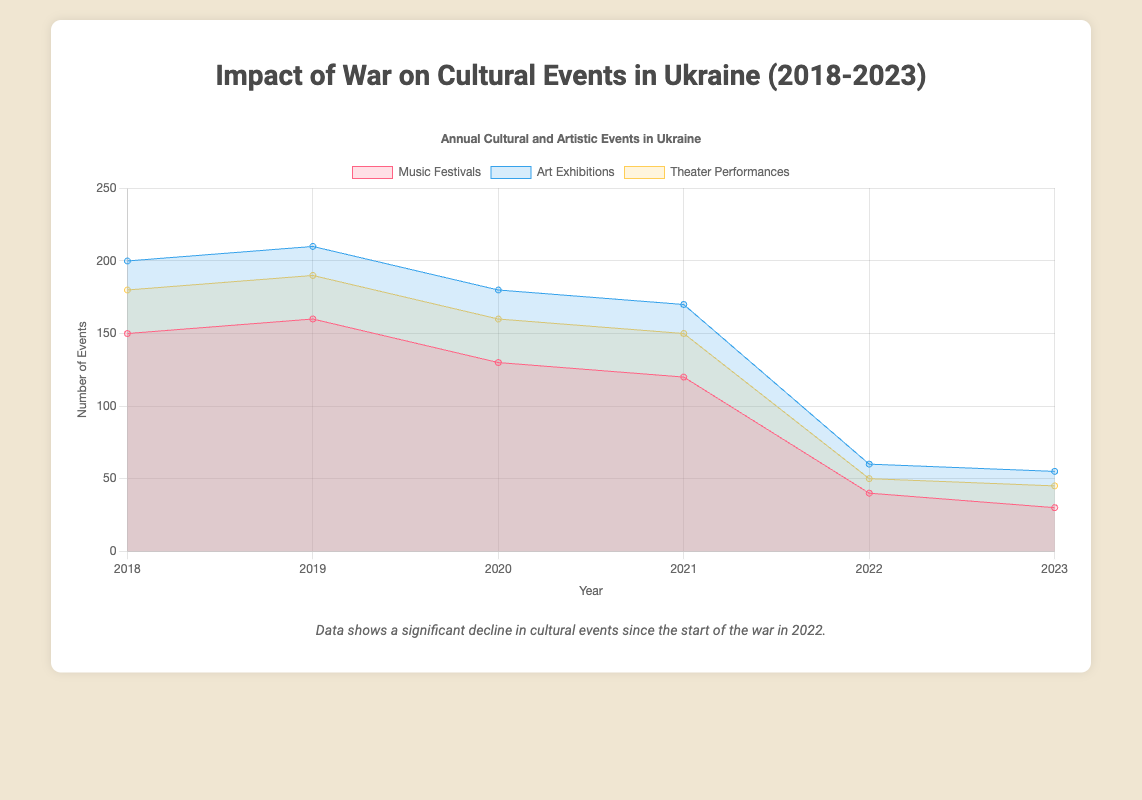What is the title of the chart? The title of the chart is located at the top and indicates the main topic of the visualization. In this case, it reads "Impact of War on Cultural Events in Ukraine (2018-2023)".
Answer: Impact of War on Cultural Events in Ukraine (2018-2023) How many event types are shown in the chart? The chart presents three different lines, each representing a different type of cultural event: Music Festivals, Art Exhibitions, and Theater Performances.
Answer: Three Which year had the highest total number of events across all event types? By visually adding up the total number of events for each year, 2019 shows a peak with maxima for Music Festivals (160), Art Exhibitions (210), and Theater Performances (190). Summing these we get 560, higher than any other year.
Answer: 2019 What is the overall trend in the number of events for 'Music Festivals' from 2018 to 2023? Observing the line representing Music Festivals, the trend is a steady decline from 150 events in 2018 to 30 events in 2023.
Answer: Decline What is the difference in the number of 'Theater Performances' between 2021 and 2022? In 2021, the number of Theater Performances was 150. In 2022, it dropped to 50. The difference is 150 - 50 = 100 events.
Answer: 100 Which event type experienced the most significant drop between 2021 and 2022? Comparing the drop in each event type's frequency: Music Festivals (120 to 40, a drop of 80), Art Exhibitions (170 to 60, a drop of 110), and Theater Performances (150 to 50, a drop of 100). Art Exhibitions experienced the largest drop of 110 events.
Answer: Art Exhibitions What is the total number of events for 'Art Exhibitions' over the entire period from 2018 to 2023? Summing up the number of Art Exhibitions for each year: 200 (2018) + 210 (2019) + 180 (2020) + 170 (2021) + 60 (2022) + 55 (2023) results in a total of 875 events.
Answer: 875 Which year saw the first noticeable decline in the number of events compared to previous years? By looking at the year-over-year changes, the first noticeable decline occurred in 2020 compared to 2019 across all three event types. For example, Music Festivals dropped from 160 to 130, and similarly for others.
Answer: 2020 What is the average number of 'Music Festivals' held annually from 2018 to 2023? Summing the 'Music Festivals' events over 6 years gives: 150 + 160 + 130 + 120 + 40 + 30 = 630. The average is thus 630 / 6 = 105.
Answer: 105 In which year did 'Theater Performances' experience the smallest number of events? Observing the trendline for Theater Performances, the smallest number of events is seen in 2023 with 45 events.
Answer: 2023 